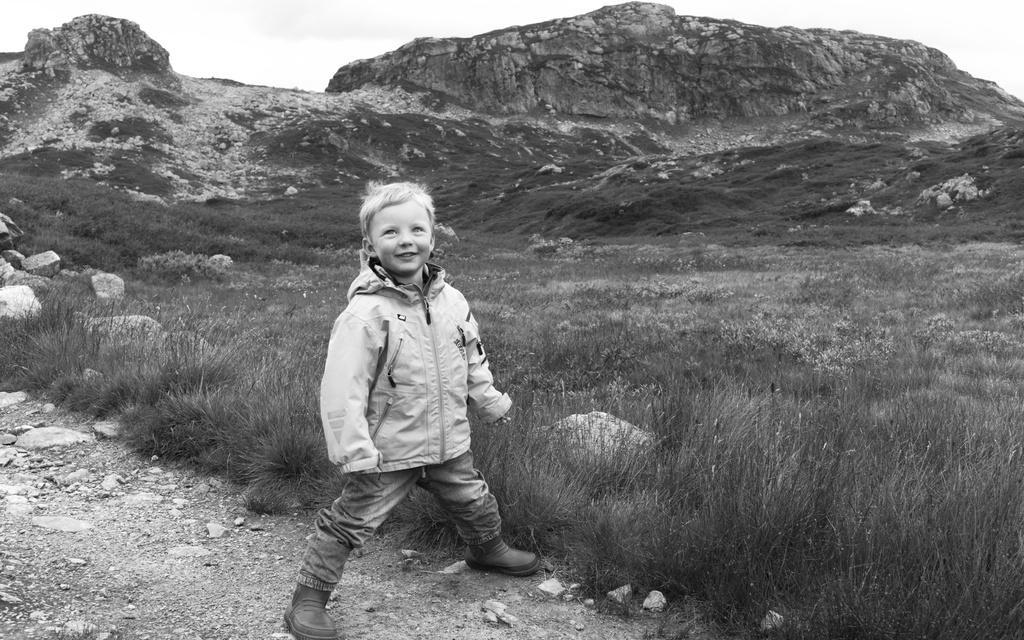Can you describe this image briefly? In this picture I can see a boy standing and I can see a smile on his face and grass on the ground and few rocks, I can see a hill and a cloudy sky in this picture 